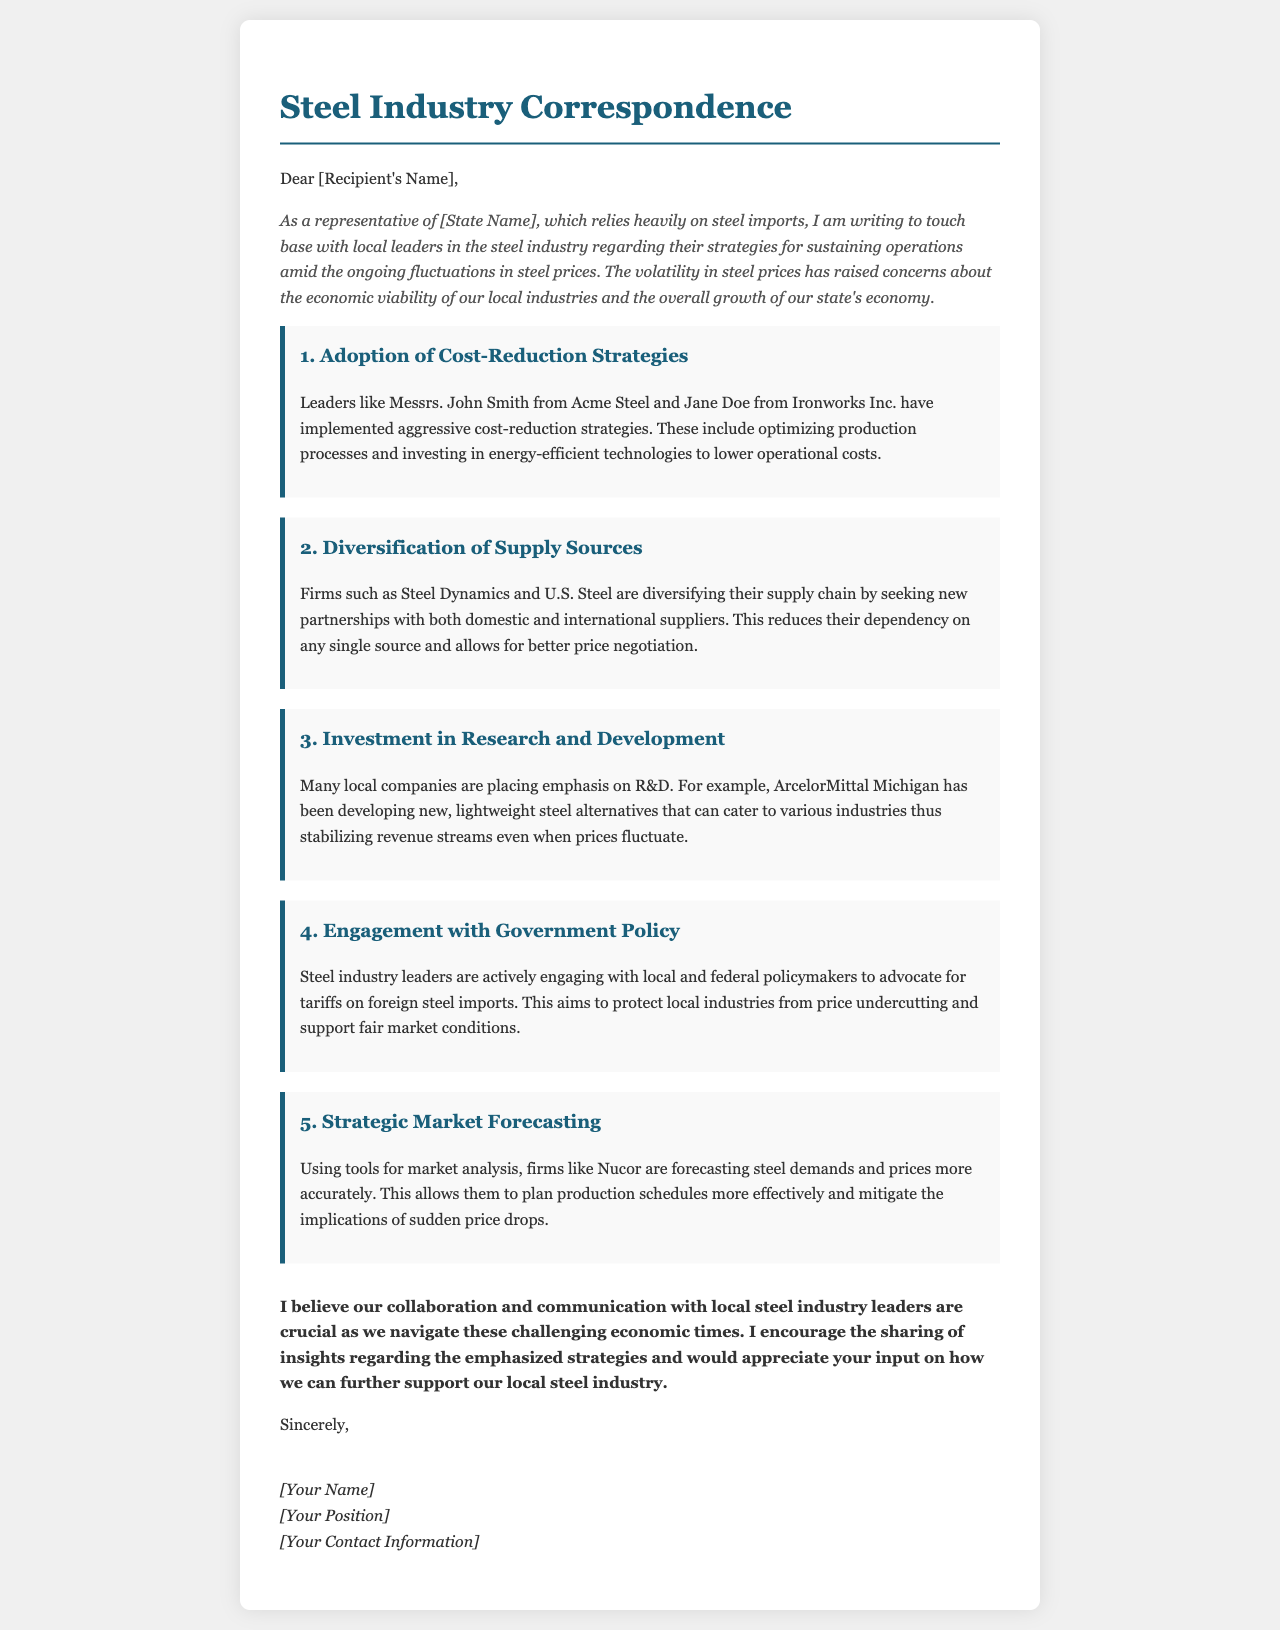What strategies have local leaders implemented? The document mentions that leaders have implemented aggressive cost-reduction strategies, including optimizing production processes and investing in energy-efficient technologies.
Answer: Cost-reduction strategies Which firm is mentioned in connection with R&D? The document specifically refers to ArcelorMittal Michigan regarding their emphasis on R&D and developing new steel alternatives.
Answer: ArcelorMittal Michigan What are firms like Nucor using for market analysis? The document states that firms like Nucor are using tools for market analysis to forecast steel demands and prices more accurately.
Answer: Tools for market analysis Who is advocating for tariffs on foreign steel imports? According to the document, steel industry leaders are actively engaging with policymakers to advocate for tariffs.
Answer: Steel industry leaders How many key strategies are discussed in the letter? The document lists five different strategies that local steel industry leaders are employing to sustain operations amid price fluctuations.
Answer: Five What is the primary concern of the letter's author? The author expresses concerns about the economic viability of local industries due to fluctuations in steel prices.
Answer: Economic viability What is the closing sentiment of the letter? The conclusion emphasizes the importance of collaboration and communication with local steel industry leaders during challenging times.
Answer: Collaboration and communication Who are the two leaders mentioned in the letter? The document mentions Messrs. John Smith from Acme Steel and Jane Doe from Ironworks Inc.
Answer: John Smith and Jane Doe 